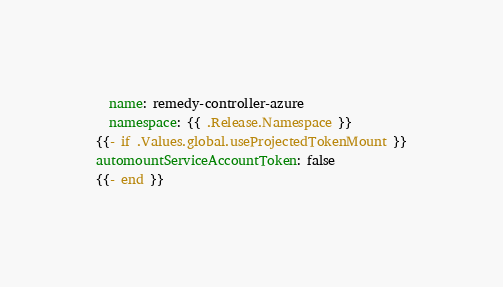Convert code to text. <code><loc_0><loc_0><loc_500><loc_500><_YAML_>  name: remedy-controller-azure
  namespace: {{ .Release.Namespace }}
{{- if .Values.global.useProjectedTokenMount }}
automountServiceAccountToken: false
{{- end }}
</code> 